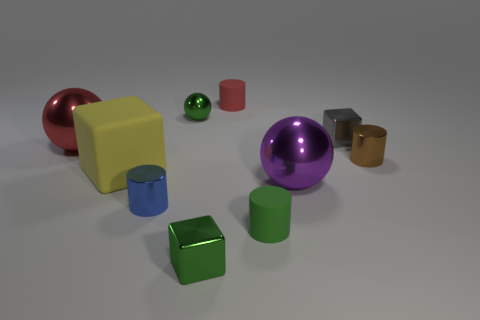Subtract all large purple balls. How many balls are left? 2 Subtract all blocks. How many objects are left? 7 Subtract all blue cylinders. How many cylinders are left? 3 Subtract 3 spheres. How many spheres are left? 0 Subtract all big red balls. Subtract all tiny rubber cylinders. How many objects are left? 7 Add 8 tiny green matte cylinders. How many tiny green matte cylinders are left? 9 Add 5 metallic blocks. How many metallic blocks exist? 7 Subtract 1 yellow blocks. How many objects are left? 9 Subtract all brown cubes. Subtract all cyan cylinders. How many cubes are left? 3 